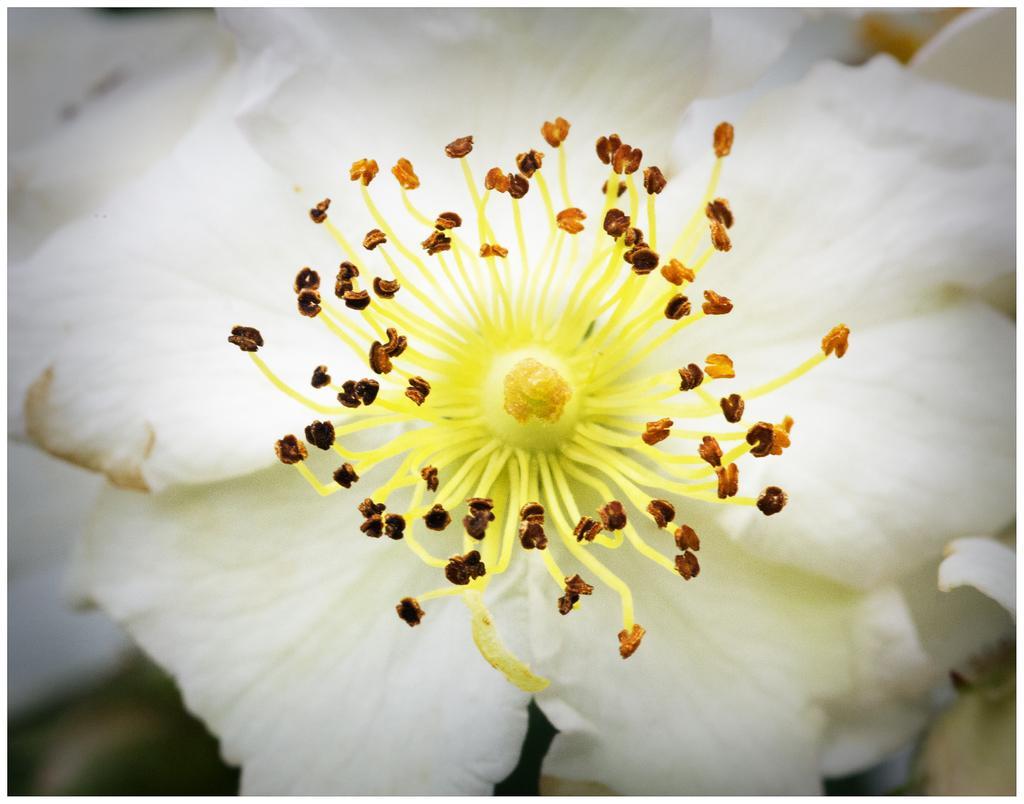Could you give a brief overview of what you see in this image? In this image there is a flower in white color. 